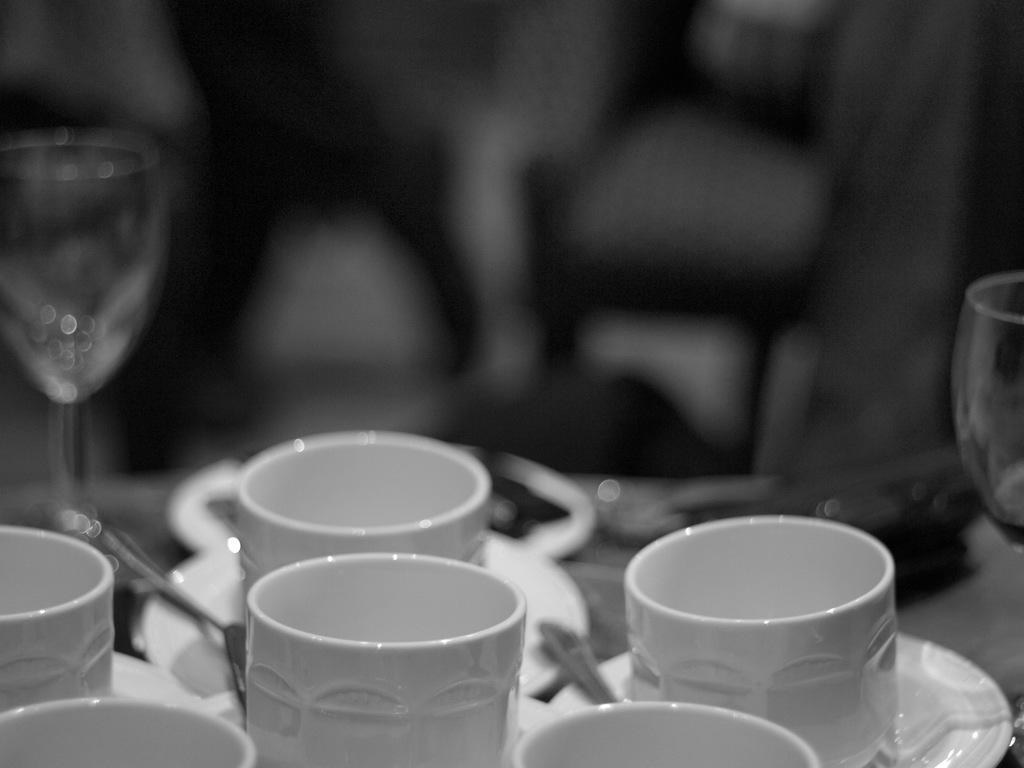Please provide a concise description of this image. In this image I can see the black and white picture in which I can see few white colored cups, few wine glasses, few spoons, few plates and the blurry background. 